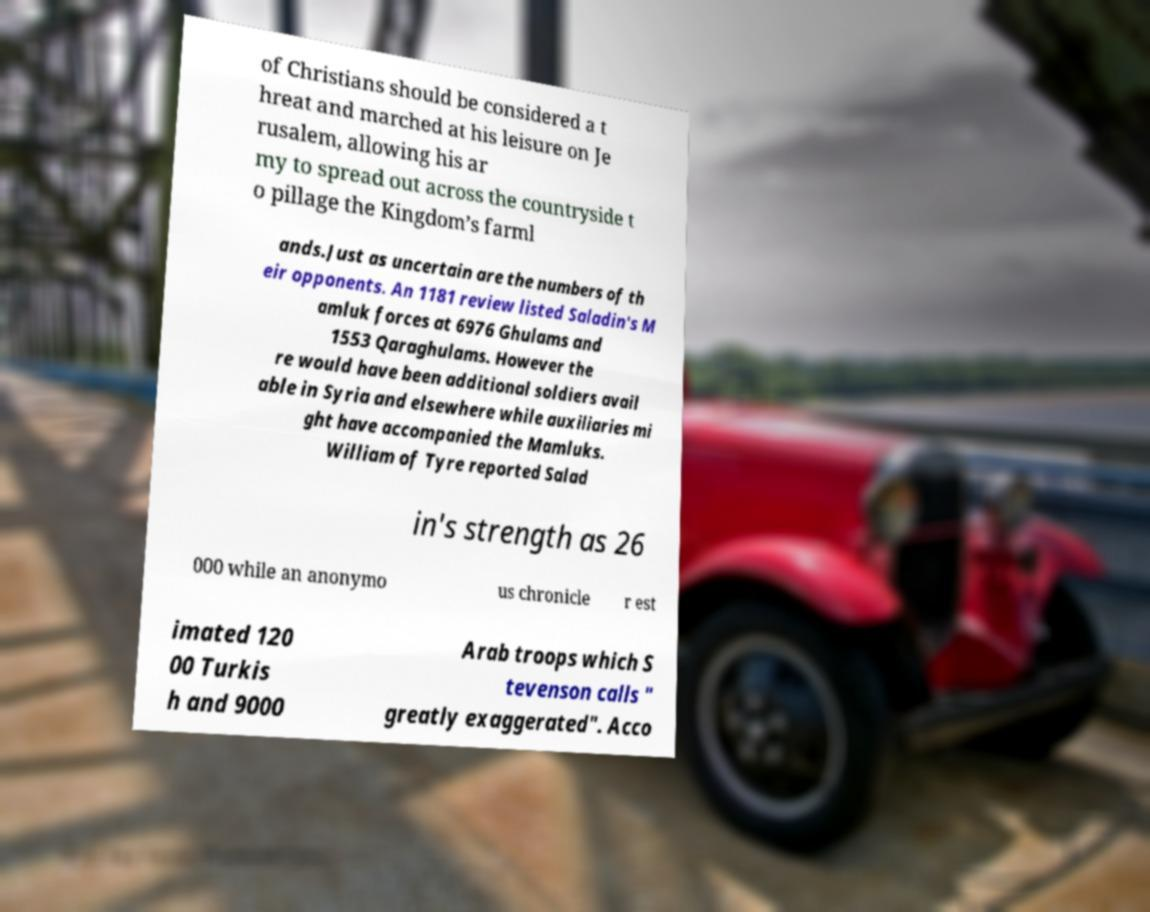Can you accurately transcribe the text from the provided image for me? of Christians should be considered a t hreat and marched at his leisure on Je rusalem, allowing his ar my to spread out across the countryside t o pillage the Kingdom’s farml ands.Just as uncertain are the numbers of th eir opponents. An 1181 review listed Saladin's M amluk forces at 6976 Ghulams and 1553 Qaraghulams. However the re would have been additional soldiers avail able in Syria and elsewhere while auxiliaries mi ght have accompanied the Mamluks. William of Tyre reported Salad in's strength as 26 000 while an anonymo us chronicle r est imated 120 00 Turkis h and 9000 Arab troops which S tevenson calls " greatly exaggerated". Acco 